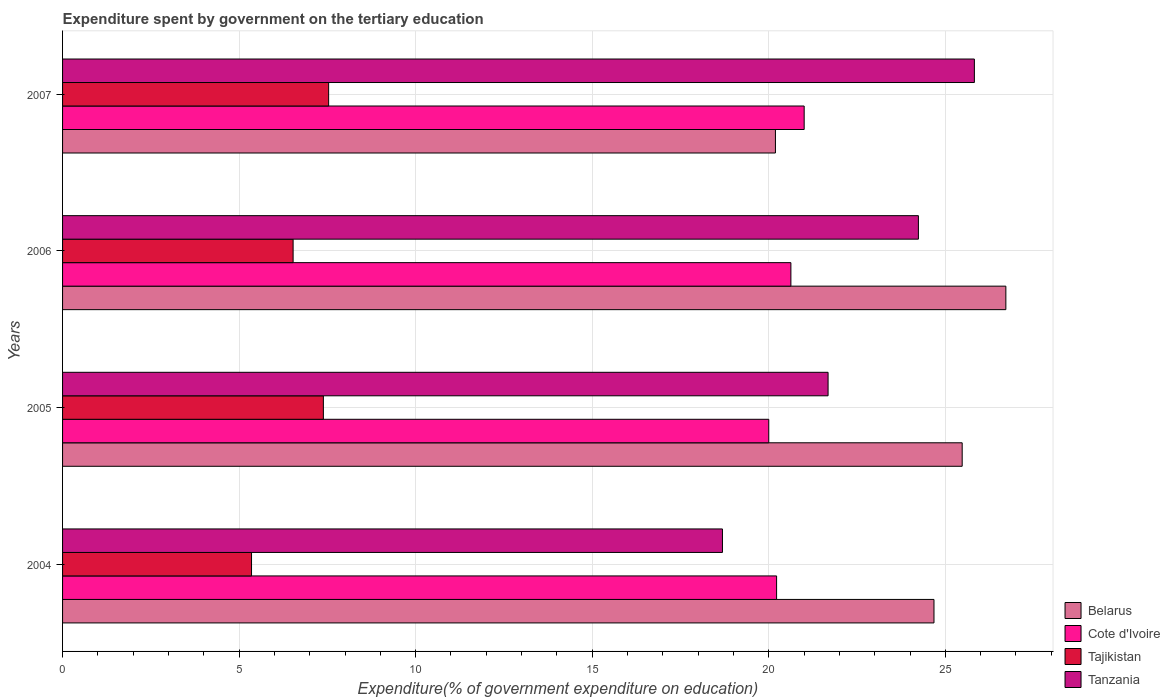Are the number of bars per tick equal to the number of legend labels?
Ensure brevity in your answer.  Yes. How many bars are there on the 1st tick from the top?
Your response must be concise. 4. What is the expenditure spent by government on the tertiary education in Tanzania in 2007?
Provide a succinct answer. 25.82. Across all years, what is the maximum expenditure spent by government on the tertiary education in Cote d'Ivoire?
Your answer should be compact. 21. Across all years, what is the minimum expenditure spent by government on the tertiary education in Tanzania?
Provide a short and direct response. 18.69. What is the total expenditure spent by government on the tertiary education in Belarus in the graph?
Provide a short and direct response. 97.06. What is the difference between the expenditure spent by government on the tertiary education in Cote d'Ivoire in 2005 and that in 2007?
Give a very brief answer. -1. What is the difference between the expenditure spent by government on the tertiary education in Tanzania in 2006 and the expenditure spent by government on the tertiary education in Belarus in 2005?
Give a very brief answer. -1.24. What is the average expenditure spent by government on the tertiary education in Tanzania per year?
Provide a short and direct response. 22.61. In the year 2007, what is the difference between the expenditure spent by government on the tertiary education in Tanzania and expenditure spent by government on the tertiary education in Cote d'Ivoire?
Your answer should be compact. 4.82. What is the ratio of the expenditure spent by government on the tertiary education in Cote d'Ivoire in 2005 to that in 2007?
Make the answer very short. 0.95. Is the expenditure spent by government on the tertiary education in Tajikistan in 2004 less than that in 2006?
Your response must be concise. Yes. What is the difference between the highest and the second highest expenditure spent by government on the tertiary education in Tanzania?
Your answer should be very brief. 1.58. What is the difference between the highest and the lowest expenditure spent by government on the tertiary education in Tanzania?
Offer a very short reply. 7.13. In how many years, is the expenditure spent by government on the tertiary education in Tanzania greater than the average expenditure spent by government on the tertiary education in Tanzania taken over all years?
Give a very brief answer. 2. Is it the case that in every year, the sum of the expenditure spent by government on the tertiary education in Tanzania and expenditure spent by government on the tertiary education in Cote d'Ivoire is greater than the sum of expenditure spent by government on the tertiary education in Belarus and expenditure spent by government on the tertiary education in Tajikistan?
Give a very brief answer. No. What does the 1st bar from the top in 2004 represents?
Your answer should be very brief. Tanzania. What does the 2nd bar from the bottom in 2005 represents?
Provide a succinct answer. Cote d'Ivoire. How many bars are there?
Keep it short and to the point. 16. Are all the bars in the graph horizontal?
Your answer should be very brief. Yes. How many years are there in the graph?
Provide a short and direct response. 4. What is the difference between two consecutive major ticks on the X-axis?
Your answer should be compact. 5. Are the values on the major ticks of X-axis written in scientific E-notation?
Offer a terse response. No. Does the graph contain any zero values?
Your answer should be very brief. No. Does the graph contain grids?
Your answer should be compact. Yes. How many legend labels are there?
Ensure brevity in your answer.  4. What is the title of the graph?
Your answer should be very brief. Expenditure spent by government on the tertiary education. Does "Croatia" appear as one of the legend labels in the graph?
Offer a very short reply. No. What is the label or title of the X-axis?
Offer a very short reply. Expenditure(% of government expenditure on education). What is the label or title of the Y-axis?
Offer a terse response. Years. What is the Expenditure(% of government expenditure on education) in Belarus in 2004?
Offer a terse response. 24.68. What is the Expenditure(% of government expenditure on education) of Cote d'Ivoire in 2004?
Provide a succinct answer. 20.22. What is the Expenditure(% of government expenditure on education) in Tajikistan in 2004?
Your answer should be compact. 5.35. What is the Expenditure(% of government expenditure on education) of Tanzania in 2004?
Offer a very short reply. 18.69. What is the Expenditure(% of government expenditure on education) in Belarus in 2005?
Provide a short and direct response. 25.48. What is the Expenditure(% of government expenditure on education) of Tajikistan in 2005?
Your answer should be compact. 7.39. What is the Expenditure(% of government expenditure on education) of Tanzania in 2005?
Make the answer very short. 21.68. What is the Expenditure(% of government expenditure on education) in Belarus in 2006?
Give a very brief answer. 26.71. What is the Expenditure(% of government expenditure on education) in Cote d'Ivoire in 2006?
Offer a terse response. 20.63. What is the Expenditure(% of government expenditure on education) of Tajikistan in 2006?
Your answer should be very brief. 6.53. What is the Expenditure(% of government expenditure on education) of Tanzania in 2006?
Your answer should be compact. 24.24. What is the Expenditure(% of government expenditure on education) of Belarus in 2007?
Your answer should be very brief. 20.19. What is the Expenditure(% of government expenditure on education) in Cote d'Ivoire in 2007?
Your response must be concise. 21. What is the Expenditure(% of government expenditure on education) of Tajikistan in 2007?
Give a very brief answer. 7.54. What is the Expenditure(% of government expenditure on education) of Tanzania in 2007?
Offer a terse response. 25.82. Across all years, what is the maximum Expenditure(% of government expenditure on education) of Belarus?
Ensure brevity in your answer.  26.71. Across all years, what is the maximum Expenditure(% of government expenditure on education) in Cote d'Ivoire?
Your answer should be very brief. 21. Across all years, what is the maximum Expenditure(% of government expenditure on education) of Tajikistan?
Offer a terse response. 7.54. Across all years, what is the maximum Expenditure(% of government expenditure on education) of Tanzania?
Make the answer very short. 25.82. Across all years, what is the minimum Expenditure(% of government expenditure on education) in Belarus?
Your answer should be compact. 20.19. Across all years, what is the minimum Expenditure(% of government expenditure on education) of Cote d'Ivoire?
Make the answer very short. 20. Across all years, what is the minimum Expenditure(% of government expenditure on education) of Tajikistan?
Keep it short and to the point. 5.35. Across all years, what is the minimum Expenditure(% of government expenditure on education) in Tanzania?
Your response must be concise. 18.69. What is the total Expenditure(% of government expenditure on education) of Belarus in the graph?
Offer a very short reply. 97.06. What is the total Expenditure(% of government expenditure on education) in Cote d'Ivoire in the graph?
Keep it short and to the point. 81.85. What is the total Expenditure(% of government expenditure on education) of Tajikistan in the graph?
Your answer should be compact. 26.8. What is the total Expenditure(% of government expenditure on education) of Tanzania in the graph?
Offer a terse response. 90.43. What is the difference between the Expenditure(% of government expenditure on education) of Belarus in 2004 and that in 2005?
Keep it short and to the point. -0.8. What is the difference between the Expenditure(% of government expenditure on education) in Cote d'Ivoire in 2004 and that in 2005?
Offer a very short reply. 0.22. What is the difference between the Expenditure(% of government expenditure on education) in Tajikistan in 2004 and that in 2005?
Ensure brevity in your answer.  -2.03. What is the difference between the Expenditure(% of government expenditure on education) of Tanzania in 2004 and that in 2005?
Keep it short and to the point. -2.99. What is the difference between the Expenditure(% of government expenditure on education) of Belarus in 2004 and that in 2006?
Provide a succinct answer. -2.04. What is the difference between the Expenditure(% of government expenditure on education) of Cote d'Ivoire in 2004 and that in 2006?
Your response must be concise. -0.41. What is the difference between the Expenditure(% of government expenditure on education) in Tajikistan in 2004 and that in 2006?
Your answer should be very brief. -1.18. What is the difference between the Expenditure(% of government expenditure on education) of Tanzania in 2004 and that in 2006?
Your response must be concise. -5.55. What is the difference between the Expenditure(% of government expenditure on education) of Belarus in 2004 and that in 2007?
Make the answer very short. 4.49. What is the difference between the Expenditure(% of government expenditure on education) of Cote d'Ivoire in 2004 and that in 2007?
Provide a succinct answer. -0.78. What is the difference between the Expenditure(% of government expenditure on education) of Tajikistan in 2004 and that in 2007?
Ensure brevity in your answer.  -2.18. What is the difference between the Expenditure(% of government expenditure on education) of Tanzania in 2004 and that in 2007?
Give a very brief answer. -7.13. What is the difference between the Expenditure(% of government expenditure on education) in Belarus in 2005 and that in 2006?
Offer a terse response. -1.24. What is the difference between the Expenditure(% of government expenditure on education) in Cote d'Ivoire in 2005 and that in 2006?
Offer a terse response. -0.63. What is the difference between the Expenditure(% of government expenditure on education) of Tajikistan in 2005 and that in 2006?
Provide a short and direct response. 0.86. What is the difference between the Expenditure(% of government expenditure on education) in Tanzania in 2005 and that in 2006?
Provide a succinct answer. -2.56. What is the difference between the Expenditure(% of government expenditure on education) in Belarus in 2005 and that in 2007?
Offer a very short reply. 5.29. What is the difference between the Expenditure(% of government expenditure on education) in Cote d'Ivoire in 2005 and that in 2007?
Your answer should be compact. -1. What is the difference between the Expenditure(% of government expenditure on education) in Tajikistan in 2005 and that in 2007?
Ensure brevity in your answer.  -0.15. What is the difference between the Expenditure(% of government expenditure on education) of Tanzania in 2005 and that in 2007?
Your answer should be very brief. -4.14. What is the difference between the Expenditure(% of government expenditure on education) in Belarus in 2006 and that in 2007?
Give a very brief answer. 6.53. What is the difference between the Expenditure(% of government expenditure on education) in Cote d'Ivoire in 2006 and that in 2007?
Offer a very short reply. -0.38. What is the difference between the Expenditure(% of government expenditure on education) in Tajikistan in 2006 and that in 2007?
Your answer should be very brief. -1.01. What is the difference between the Expenditure(% of government expenditure on education) in Tanzania in 2006 and that in 2007?
Provide a succinct answer. -1.58. What is the difference between the Expenditure(% of government expenditure on education) in Belarus in 2004 and the Expenditure(% of government expenditure on education) in Cote d'Ivoire in 2005?
Give a very brief answer. 4.68. What is the difference between the Expenditure(% of government expenditure on education) of Belarus in 2004 and the Expenditure(% of government expenditure on education) of Tajikistan in 2005?
Your answer should be compact. 17.29. What is the difference between the Expenditure(% of government expenditure on education) of Belarus in 2004 and the Expenditure(% of government expenditure on education) of Tanzania in 2005?
Provide a short and direct response. 3. What is the difference between the Expenditure(% of government expenditure on education) in Cote d'Ivoire in 2004 and the Expenditure(% of government expenditure on education) in Tajikistan in 2005?
Your response must be concise. 12.84. What is the difference between the Expenditure(% of government expenditure on education) in Cote d'Ivoire in 2004 and the Expenditure(% of government expenditure on education) in Tanzania in 2005?
Provide a succinct answer. -1.46. What is the difference between the Expenditure(% of government expenditure on education) in Tajikistan in 2004 and the Expenditure(% of government expenditure on education) in Tanzania in 2005?
Offer a terse response. -16.33. What is the difference between the Expenditure(% of government expenditure on education) in Belarus in 2004 and the Expenditure(% of government expenditure on education) in Cote d'Ivoire in 2006?
Your answer should be compact. 4.05. What is the difference between the Expenditure(% of government expenditure on education) in Belarus in 2004 and the Expenditure(% of government expenditure on education) in Tajikistan in 2006?
Provide a short and direct response. 18.15. What is the difference between the Expenditure(% of government expenditure on education) in Belarus in 2004 and the Expenditure(% of government expenditure on education) in Tanzania in 2006?
Your answer should be very brief. 0.44. What is the difference between the Expenditure(% of government expenditure on education) of Cote d'Ivoire in 2004 and the Expenditure(% of government expenditure on education) of Tajikistan in 2006?
Offer a very short reply. 13.69. What is the difference between the Expenditure(% of government expenditure on education) in Cote d'Ivoire in 2004 and the Expenditure(% of government expenditure on education) in Tanzania in 2006?
Offer a terse response. -4.02. What is the difference between the Expenditure(% of government expenditure on education) of Tajikistan in 2004 and the Expenditure(% of government expenditure on education) of Tanzania in 2006?
Provide a succinct answer. -18.89. What is the difference between the Expenditure(% of government expenditure on education) of Belarus in 2004 and the Expenditure(% of government expenditure on education) of Cote d'Ivoire in 2007?
Your answer should be compact. 3.68. What is the difference between the Expenditure(% of government expenditure on education) of Belarus in 2004 and the Expenditure(% of government expenditure on education) of Tajikistan in 2007?
Provide a succinct answer. 17.14. What is the difference between the Expenditure(% of government expenditure on education) of Belarus in 2004 and the Expenditure(% of government expenditure on education) of Tanzania in 2007?
Make the answer very short. -1.14. What is the difference between the Expenditure(% of government expenditure on education) in Cote d'Ivoire in 2004 and the Expenditure(% of government expenditure on education) in Tajikistan in 2007?
Provide a short and direct response. 12.69. What is the difference between the Expenditure(% of government expenditure on education) of Cote d'Ivoire in 2004 and the Expenditure(% of government expenditure on education) of Tanzania in 2007?
Provide a short and direct response. -5.6. What is the difference between the Expenditure(% of government expenditure on education) of Tajikistan in 2004 and the Expenditure(% of government expenditure on education) of Tanzania in 2007?
Provide a succinct answer. -20.47. What is the difference between the Expenditure(% of government expenditure on education) of Belarus in 2005 and the Expenditure(% of government expenditure on education) of Cote d'Ivoire in 2006?
Ensure brevity in your answer.  4.85. What is the difference between the Expenditure(% of government expenditure on education) of Belarus in 2005 and the Expenditure(% of government expenditure on education) of Tajikistan in 2006?
Provide a succinct answer. 18.95. What is the difference between the Expenditure(% of government expenditure on education) of Belarus in 2005 and the Expenditure(% of government expenditure on education) of Tanzania in 2006?
Offer a terse response. 1.24. What is the difference between the Expenditure(% of government expenditure on education) in Cote d'Ivoire in 2005 and the Expenditure(% of government expenditure on education) in Tajikistan in 2006?
Your answer should be compact. 13.47. What is the difference between the Expenditure(% of government expenditure on education) of Cote d'Ivoire in 2005 and the Expenditure(% of government expenditure on education) of Tanzania in 2006?
Your response must be concise. -4.24. What is the difference between the Expenditure(% of government expenditure on education) in Tajikistan in 2005 and the Expenditure(% of government expenditure on education) in Tanzania in 2006?
Offer a very short reply. -16.85. What is the difference between the Expenditure(% of government expenditure on education) in Belarus in 2005 and the Expenditure(% of government expenditure on education) in Cote d'Ivoire in 2007?
Keep it short and to the point. 4.48. What is the difference between the Expenditure(% of government expenditure on education) of Belarus in 2005 and the Expenditure(% of government expenditure on education) of Tajikistan in 2007?
Give a very brief answer. 17.94. What is the difference between the Expenditure(% of government expenditure on education) of Belarus in 2005 and the Expenditure(% of government expenditure on education) of Tanzania in 2007?
Provide a succinct answer. -0.35. What is the difference between the Expenditure(% of government expenditure on education) in Cote d'Ivoire in 2005 and the Expenditure(% of government expenditure on education) in Tajikistan in 2007?
Offer a terse response. 12.46. What is the difference between the Expenditure(% of government expenditure on education) of Cote d'Ivoire in 2005 and the Expenditure(% of government expenditure on education) of Tanzania in 2007?
Provide a short and direct response. -5.82. What is the difference between the Expenditure(% of government expenditure on education) of Tajikistan in 2005 and the Expenditure(% of government expenditure on education) of Tanzania in 2007?
Your answer should be compact. -18.44. What is the difference between the Expenditure(% of government expenditure on education) in Belarus in 2006 and the Expenditure(% of government expenditure on education) in Cote d'Ivoire in 2007?
Your answer should be compact. 5.71. What is the difference between the Expenditure(% of government expenditure on education) of Belarus in 2006 and the Expenditure(% of government expenditure on education) of Tajikistan in 2007?
Give a very brief answer. 19.18. What is the difference between the Expenditure(% of government expenditure on education) in Belarus in 2006 and the Expenditure(% of government expenditure on education) in Tanzania in 2007?
Your answer should be compact. 0.89. What is the difference between the Expenditure(% of government expenditure on education) of Cote d'Ivoire in 2006 and the Expenditure(% of government expenditure on education) of Tajikistan in 2007?
Offer a terse response. 13.09. What is the difference between the Expenditure(% of government expenditure on education) of Cote d'Ivoire in 2006 and the Expenditure(% of government expenditure on education) of Tanzania in 2007?
Your response must be concise. -5.2. What is the difference between the Expenditure(% of government expenditure on education) of Tajikistan in 2006 and the Expenditure(% of government expenditure on education) of Tanzania in 2007?
Offer a terse response. -19.29. What is the average Expenditure(% of government expenditure on education) of Belarus per year?
Your answer should be compact. 24.26. What is the average Expenditure(% of government expenditure on education) in Cote d'Ivoire per year?
Provide a succinct answer. 20.46. What is the average Expenditure(% of government expenditure on education) in Tajikistan per year?
Make the answer very short. 6.7. What is the average Expenditure(% of government expenditure on education) in Tanzania per year?
Keep it short and to the point. 22.61. In the year 2004, what is the difference between the Expenditure(% of government expenditure on education) in Belarus and Expenditure(% of government expenditure on education) in Cote d'Ivoire?
Your response must be concise. 4.46. In the year 2004, what is the difference between the Expenditure(% of government expenditure on education) of Belarus and Expenditure(% of government expenditure on education) of Tajikistan?
Provide a succinct answer. 19.33. In the year 2004, what is the difference between the Expenditure(% of government expenditure on education) of Belarus and Expenditure(% of government expenditure on education) of Tanzania?
Provide a short and direct response. 5.99. In the year 2004, what is the difference between the Expenditure(% of government expenditure on education) of Cote d'Ivoire and Expenditure(% of government expenditure on education) of Tajikistan?
Offer a very short reply. 14.87. In the year 2004, what is the difference between the Expenditure(% of government expenditure on education) in Cote d'Ivoire and Expenditure(% of government expenditure on education) in Tanzania?
Ensure brevity in your answer.  1.53. In the year 2004, what is the difference between the Expenditure(% of government expenditure on education) in Tajikistan and Expenditure(% of government expenditure on education) in Tanzania?
Make the answer very short. -13.34. In the year 2005, what is the difference between the Expenditure(% of government expenditure on education) of Belarus and Expenditure(% of government expenditure on education) of Cote d'Ivoire?
Give a very brief answer. 5.48. In the year 2005, what is the difference between the Expenditure(% of government expenditure on education) of Belarus and Expenditure(% of government expenditure on education) of Tajikistan?
Give a very brief answer. 18.09. In the year 2005, what is the difference between the Expenditure(% of government expenditure on education) in Belarus and Expenditure(% of government expenditure on education) in Tanzania?
Offer a terse response. 3.8. In the year 2005, what is the difference between the Expenditure(% of government expenditure on education) in Cote d'Ivoire and Expenditure(% of government expenditure on education) in Tajikistan?
Provide a short and direct response. 12.61. In the year 2005, what is the difference between the Expenditure(% of government expenditure on education) in Cote d'Ivoire and Expenditure(% of government expenditure on education) in Tanzania?
Ensure brevity in your answer.  -1.68. In the year 2005, what is the difference between the Expenditure(% of government expenditure on education) of Tajikistan and Expenditure(% of government expenditure on education) of Tanzania?
Offer a very short reply. -14.29. In the year 2006, what is the difference between the Expenditure(% of government expenditure on education) of Belarus and Expenditure(% of government expenditure on education) of Cote d'Ivoire?
Provide a succinct answer. 6.09. In the year 2006, what is the difference between the Expenditure(% of government expenditure on education) of Belarus and Expenditure(% of government expenditure on education) of Tajikistan?
Offer a terse response. 20.19. In the year 2006, what is the difference between the Expenditure(% of government expenditure on education) of Belarus and Expenditure(% of government expenditure on education) of Tanzania?
Your response must be concise. 2.48. In the year 2006, what is the difference between the Expenditure(% of government expenditure on education) of Cote d'Ivoire and Expenditure(% of government expenditure on education) of Tajikistan?
Your answer should be very brief. 14.1. In the year 2006, what is the difference between the Expenditure(% of government expenditure on education) in Cote d'Ivoire and Expenditure(% of government expenditure on education) in Tanzania?
Your answer should be very brief. -3.61. In the year 2006, what is the difference between the Expenditure(% of government expenditure on education) in Tajikistan and Expenditure(% of government expenditure on education) in Tanzania?
Offer a very short reply. -17.71. In the year 2007, what is the difference between the Expenditure(% of government expenditure on education) of Belarus and Expenditure(% of government expenditure on education) of Cote d'Ivoire?
Your answer should be very brief. -0.81. In the year 2007, what is the difference between the Expenditure(% of government expenditure on education) of Belarus and Expenditure(% of government expenditure on education) of Tajikistan?
Offer a terse response. 12.65. In the year 2007, what is the difference between the Expenditure(% of government expenditure on education) in Belarus and Expenditure(% of government expenditure on education) in Tanzania?
Provide a succinct answer. -5.63. In the year 2007, what is the difference between the Expenditure(% of government expenditure on education) in Cote d'Ivoire and Expenditure(% of government expenditure on education) in Tajikistan?
Ensure brevity in your answer.  13.47. In the year 2007, what is the difference between the Expenditure(% of government expenditure on education) of Cote d'Ivoire and Expenditure(% of government expenditure on education) of Tanzania?
Ensure brevity in your answer.  -4.82. In the year 2007, what is the difference between the Expenditure(% of government expenditure on education) in Tajikistan and Expenditure(% of government expenditure on education) in Tanzania?
Offer a very short reply. -18.29. What is the ratio of the Expenditure(% of government expenditure on education) of Belarus in 2004 to that in 2005?
Offer a very short reply. 0.97. What is the ratio of the Expenditure(% of government expenditure on education) of Cote d'Ivoire in 2004 to that in 2005?
Provide a short and direct response. 1.01. What is the ratio of the Expenditure(% of government expenditure on education) of Tajikistan in 2004 to that in 2005?
Your answer should be very brief. 0.72. What is the ratio of the Expenditure(% of government expenditure on education) in Tanzania in 2004 to that in 2005?
Give a very brief answer. 0.86. What is the ratio of the Expenditure(% of government expenditure on education) of Belarus in 2004 to that in 2006?
Provide a short and direct response. 0.92. What is the ratio of the Expenditure(% of government expenditure on education) of Cote d'Ivoire in 2004 to that in 2006?
Provide a succinct answer. 0.98. What is the ratio of the Expenditure(% of government expenditure on education) of Tajikistan in 2004 to that in 2006?
Make the answer very short. 0.82. What is the ratio of the Expenditure(% of government expenditure on education) in Tanzania in 2004 to that in 2006?
Offer a very short reply. 0.77. What is the ratio of the Expenditure(% of government expenditure on education) of Belarus in 2004 to that in 2007?
Offer a very short reply. 1.22. What is the ratio of the Expenditure(% of government expenditure on education) of Cote d'Ivoire in 2004 to that in 2007?
Ensure brevity in your answer.  0.96. What is the ratio of the Expenditure(% of government expenditure on education) in Tajikistan in 2004 to that in 2007?
Ensure brevity in your answer.  0.71. What is the ratio of the Expenditure(% of government expenditure on education) of Tanzania in 2004 to that in 2007?
Provide a succinct answer. 0.72. What is the ratio of the Expenditure(% of government expenditure on education) of Belarus in 2005 to that in 2006?
Provide a short and direct response. 0.95. What is the ratio of the Expenditure(% of government expenditure on education) in Cote d'Ivoire in 2005 to that in 2006?
Provide a short and direct response. 0.97. What is the ratio of the Expenditure(% of government expenditure on education) in Tajikistan in 2005 to that in 2006?
Give a very brief answer. 1.13. What is the ratio of the Expenditure(% of government expenditure on education) of Tanzania in 2005 to that in 2006?
Give a very brief answer. 0.89. What is the ratio of the Expenditure(% of government expenditure on education) in Belarus in 2005 to that in 2007?
Ensure brevity in your answer.  1.26. What is the ratio of the Expenditure(% of government expenditure on education) in Cote d'Ivoire in 2005 to that in 2007?
Your answer should be very brief. 0.95. What is the ratio of the Expenditure(% of government expenditure on education) in Tajikistan in 2005 to that in 2007?
Ensure brevity in your answer.  0.98. What is the ratio of the Expenditure(% of government expenditure on education) in Tanzania in 2005 to that in 2007?
Provide a short and direct response. 0.84. What is the ratio of the Expenditure(% of government expenditure on education) in Belarus in 2006 to that in 2007?
Keep it short and to the point. 1.32. What is the ratio of the Expenditure(% of government expenditure on education) in Cote d'Ivoire in 2006 to that in 2007?
Give a very brief answer. 0.98. What is the ratio of the Expenditure(% of government expenditure on education) in Tajikistan in 2006 to that in 2007?
Offer a terse response. 0.87. What is the ratio of the Expenditure(% of government expenditure on education) of Tanzania in 2006 to that in 2007?
Provide a succinct answer. 0.94. What is the difference between the highest and the second highest Expenditure(% of government expenditure on education) in Belarus?
Make the answer very short. 1.24. What is the difference between the highest and the second highest Expenditure(% of government expenditure on education) in Cote d'Ivoire?
Provide a succinct answer. 0.38. What is the difference between the highest and the second highest Expenditure(% of government expenditure on education) of Tajikistan?
Provide a short and direct response. 0.15. What is the difference between the highest and the second highest Expenditure(% of government expenditure on education) of Tanzania?
Give a very brief answer. 1.58. What is the difference between the highest and the lowest Expenditure(% of government expenditure on education) of Belarus?
Keep it short and to the point. 6.53. What is the difference between the highest and the lowest Expenditure(% of government expenditure on education) in Cote d'Ivoire?
Make the answer very short. 1. What is the difference between the highest and the lowest Expenditure(% of government expenditure on education) of Tajikistan?
Provide a short and direct response. 2.18. What is the difference between the highest and the lowest Expenditure(% of government expenditure on education) in Tanzania?
Provide a succinct answer. 7.13. 